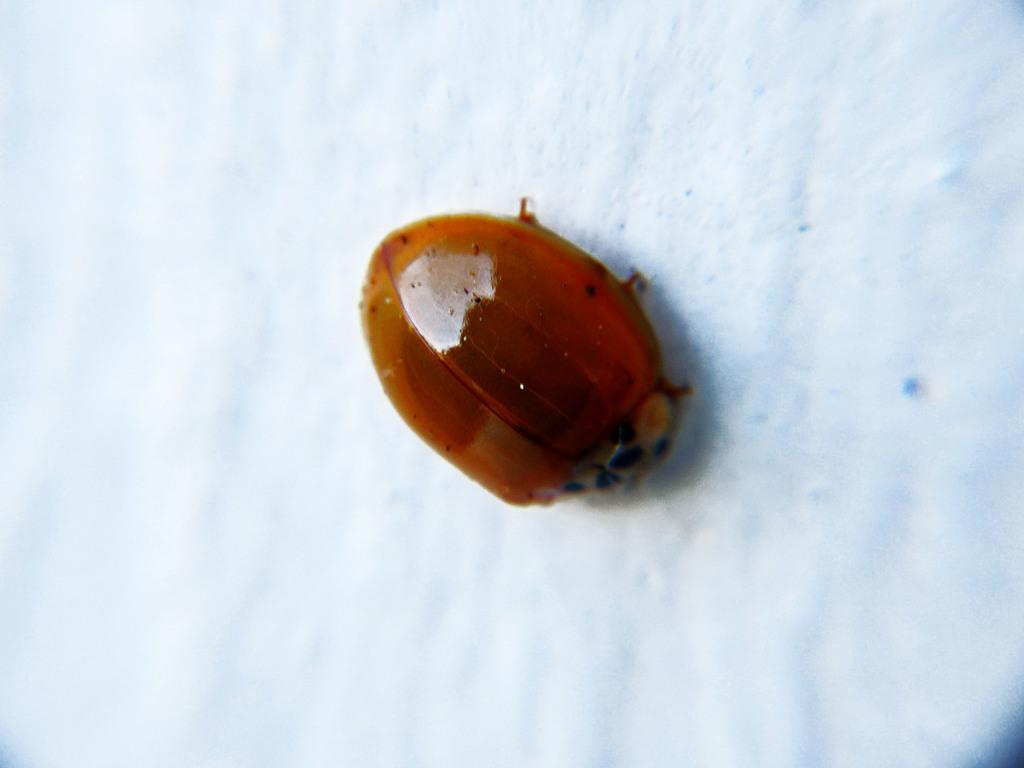What is present on the white surface in the image? There is a bug on the white surface in the image. Can you describe the color of the bug? The provided facts do not mention the color of the bug. What is the background of the image? The background of the image is a white surface. How many accounts does the bug have in the image? There are no accounts present in the image, as it features a bug on a white surface. 